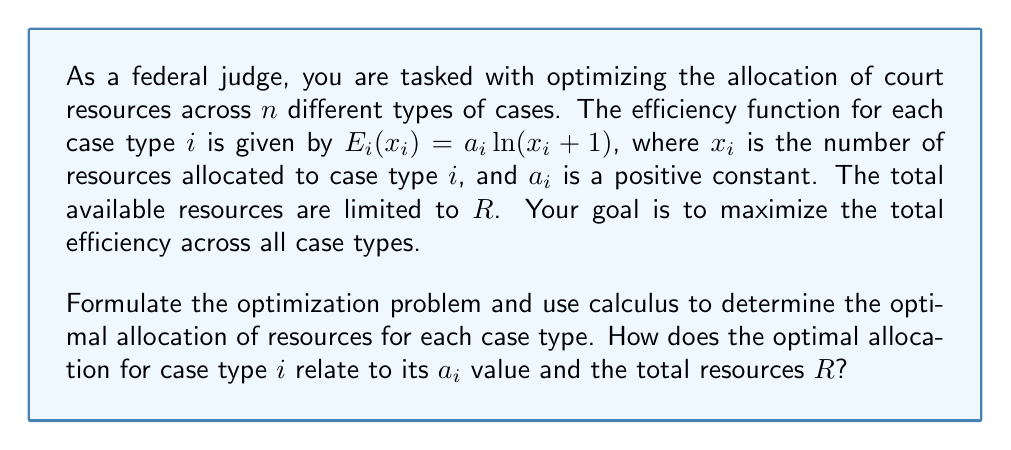Solve this math problem. To solve this optimization problem, we'll follow these steps:

1) First, let's formulate the optimization problem:

   Maximize: $\sum_{i=1}^n E_i(x_i) = \sum_{i=1}^n a_i\ln(x_i + 1)$
   Subject to: $\sum_{i=1}^n x_i = R$ and $x_i \geq 0$ for all $i$

2) We can use the method of Lagrange multipliers. Let's define the Lagrangian:

   $L(x_1, ..., x_n, \lambda) = \sum_{i=1}^n a_i\ln(x_i + 1) - \lambda(\sum_{i=1}^n x_i - R)$

3) For the optimal solution, we need:

   $\frac{\partial L}{\partial x_i} = \frac{a_i}{x_i + 1} - \lambda = 0$ for all $i$
   $\frac{\partial L}{\partial \lambda} = R - \sum_{i=1}^n x_i = 0$

4) From the first condition:

   $\frac{a_i}{x_i + 1} = \lambda$ for all $i$

   This means: $x_i + 1 = \frac{a_i}{\lambda}$ or $x_i = \frac{a_i}{\lambda} - 1$ for all $i$

5) Substituting this into the second condition:

   $R = \sum_{i=1}^n (\frac{a_i}{\lambda} - 1) = \frac{1}{\lambda}\sum_{i=1}^n a_i - n$

6) Solving for $\lambda$:

   $\lambda = \frac{\sum_{i=1}^n a_i}{R + n}$

7) Substituting this back into the expression for $x_i$:

   $x_i = \frac{a_i}{\frac{\sum_{i=1}^n a_i}{R + n}} - 1 = \frac{a_i(R + n)}{\sum_{i=1}^n a_i} - 1$

This gives us the optimal allocation for each case type $i$ in terms of its $a_i$ value, the total resources $R$, and the sum of all $a_i$ values.
Answer: The optimal allocation for case type $i$ is:

$$x_i = \frac{a_i(R + n)}{\sum_{i=1}^n a_i} - 1$$

This shows that the optimal allocation is proportional to the $a_i$ value of each case type, adjusted by a factor that depends on the total resources $R$ and the number of case types $n$. 